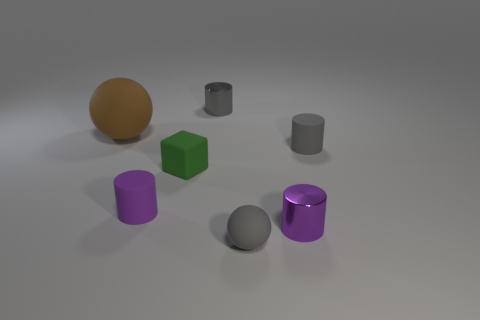Subtract all red cylinders. How many brown balls are left? 1 Subtract all small cylinders. Subtract all tiny purple cylinders. How many objects are left? 1 Add 4 gray things. How many gray things are left? 7 Add 2 small blue metal objects. How many small blue metal objects exist? 2 Add 3 matte blocks. How many objects exist? 10 Subtract all brown spheres. How many spheres are left? 1 Subtract all tiny gray metallic cylinders. How many cylinders are left? 3 Subtract 1 brown balls. How many objects are left? 6 Subtract all cylinders. How many objects are left? 3 Subtract 1 cylinders. How many cylinders are left? 3 